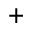Convert formula to latex. <formula><loc_0><loc_0><loc_500><loc_500>^ { + }</formula> 